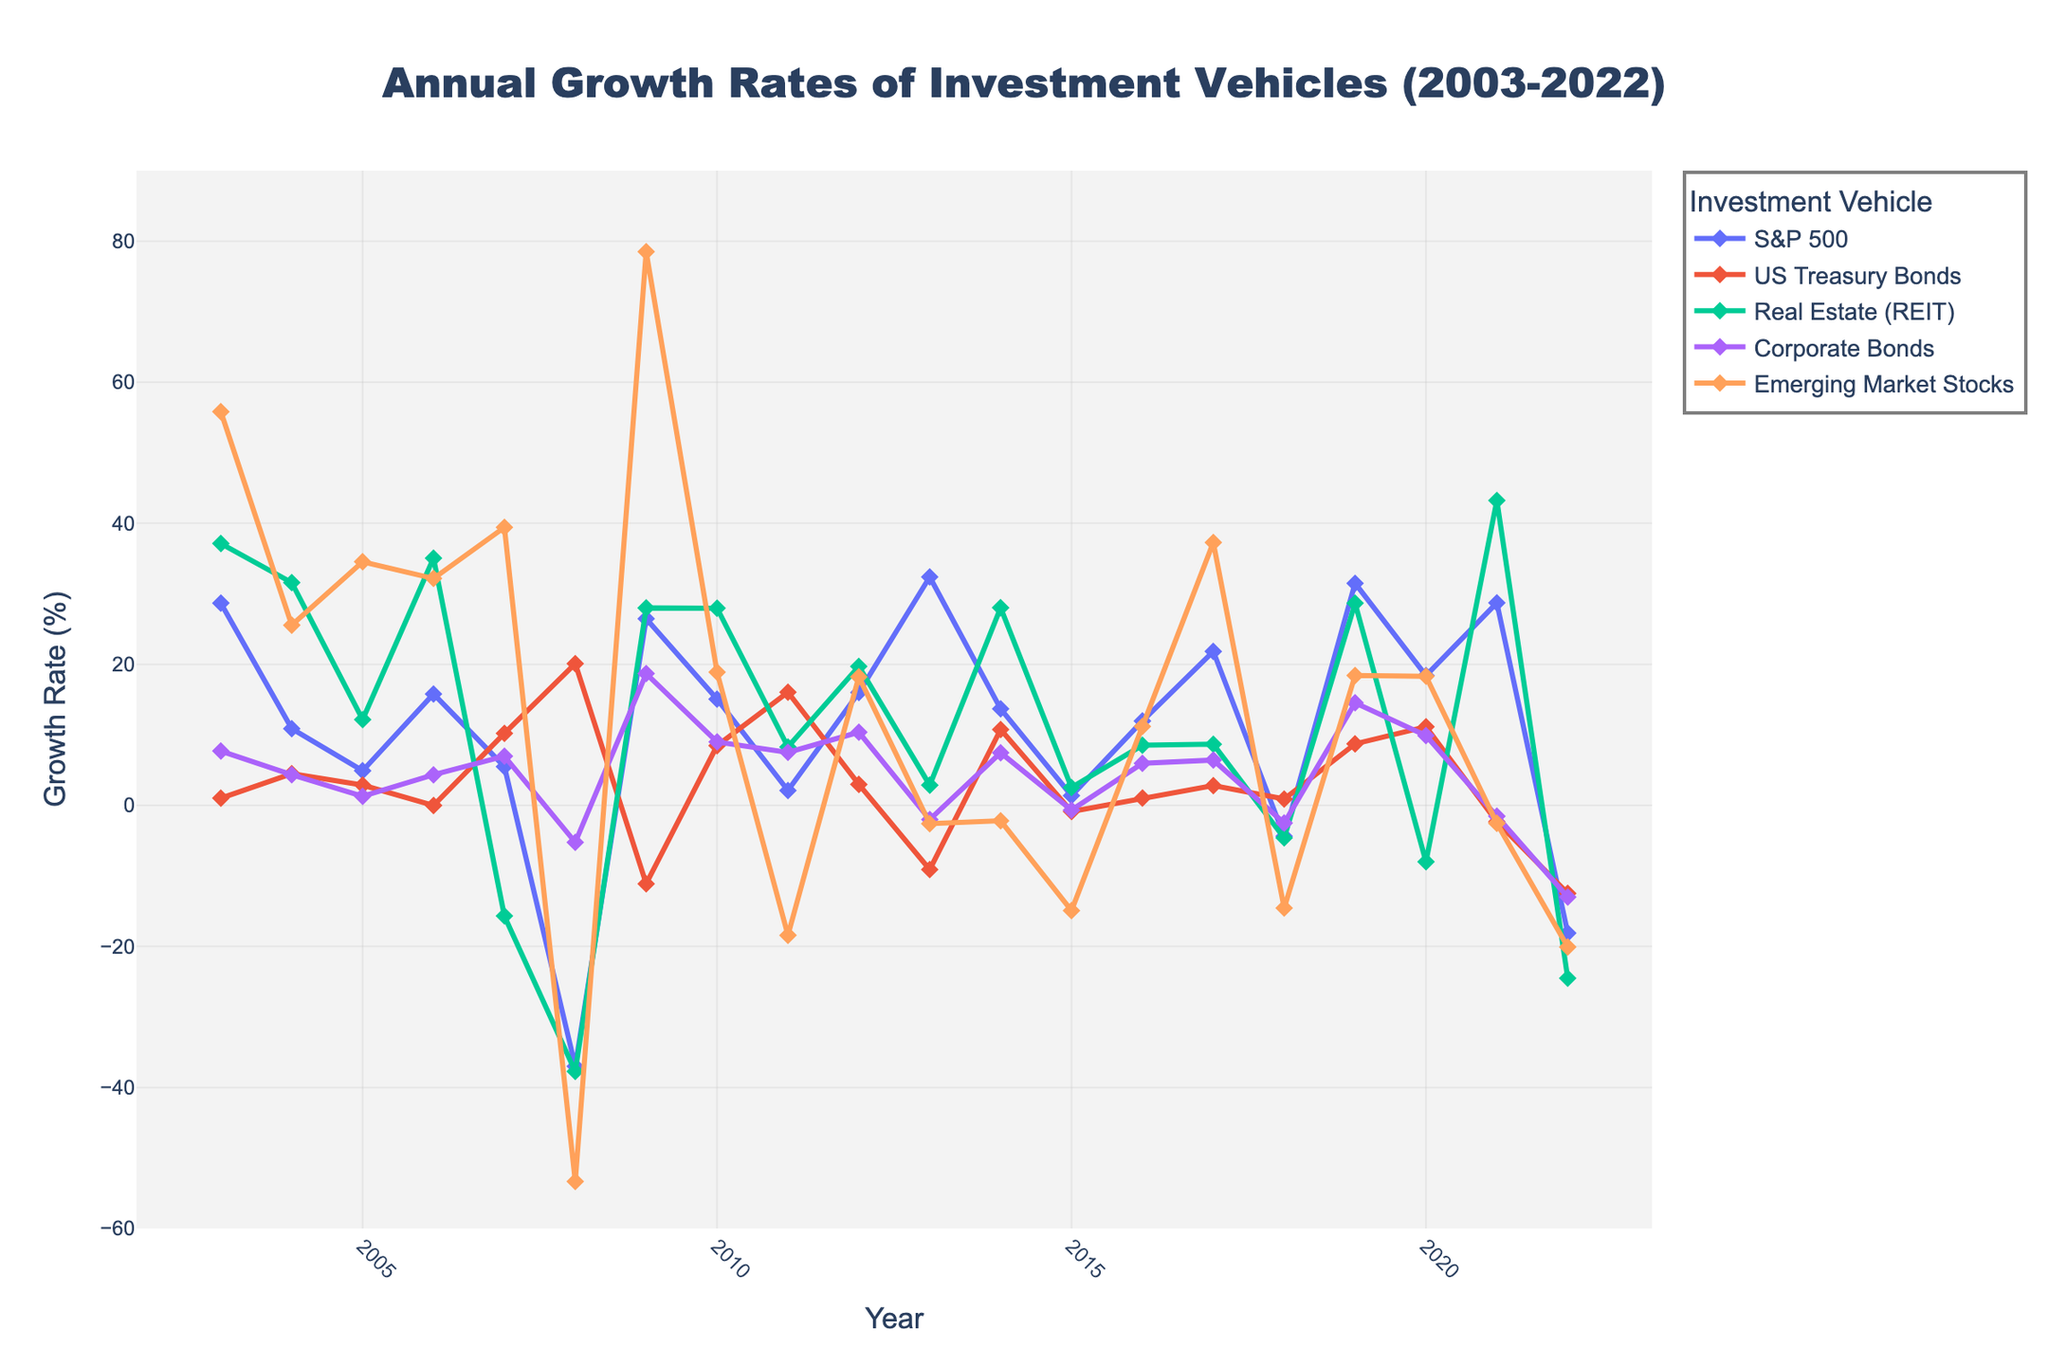What was the growth rate of S&P 500 in 2022 and how does it compare to 2008? Look at the S&P 500 data points for 2022 and 2008. In 2022, the growth rate is -18.11% and in 2008, it is -37.00%. The S&P 500 had a higher growth rate (less negative) in 2022 compared to 2008.
Answer: -18.11% in 2022 vs -37.00% in 2008 Which investment vehicle had the highest growth rate in 2019? Identify the line representing the year 2019 and compare the peaks. Emerging Market Stocks had a growth rate of 18.42%, Corporate Bonds had 14.54%, US Treasury Bonds had 8.72%, Real Estate (REIT) had 28.66%, and S&P 500 had 31.49%. S&P 500 had the highest growth rate in 2019.
Answer: S&P 500 What was the overall trend for Real Estate (REIT) from 2003 to 2022? Examine the line representing Real Estate (REIT) over the years from 2003 to 2022. Observe the fluctuations and the direction of the peaks. It started strong, experienced significant drops in 2007, 2008, 2015, and then large drops again in 2022.
Answer: Fluctuating with significant drops How did Emerging Market Stocks perform in 2008 compared to Corporate Bonds? Look at the data points for 2008 for both Emerging Market Stocks (-53.33%) and Corporate Bonds (-5.24%). Emerging Market Stocks performed much worse than Corporate Bonds in 2008.
Answer: Worse In which years did US Treasury Bonds have a negative growth rate? Analyze the US Treasury Bonds line and identify the years where the growth rate drops below 0%: 2006, 2009, 2013, 2015, 2021, and 2022 had negative growth rates.
Answer: 2006, 2009, 2013, 2015, 2021, and 2022 What was the most volatile investment vehicle over the 20 years, based on peaks and troughs? Compare the fluctuations in the lines of each investment vehicle. Emerging Market Stocks had significant peaks and troughs, especially with a huge peak in 2003 and a significant drop in 2008.
Answer: Emerging Market Stocks What was the average growth rate for Corporate Bonds between 2010 and 2015? Calculate the average of Corporate Bonds growth rates for 2010 (9.00%), 2011 (7.51%), 2012 (10.37%), 2013 (-2.01%), 2014 (7.46%), and 2015 (-0.68%). Sum these (9.00 + 7.51 + 10.37 + (-2.01) + 7.46 + (-0.68)) = 31.65 and then divide by 6.
Answer: 5.275% Compare the performance of Real Estate (REIT) in 2007 and 2009. Examine the growth rates for Real Estate (REIT) in 2007 (-15.69%) and 2009 (27.99%). The performance shifted from negative in 2007 to a positive growth rate in 2009.
Answer: Improved Which investment vehicle had the worst performance in 2022 and what was its growth rate? Look at the data points for 2022 and compare the values. Emerging Market Stocks had the worst performance with a growth rate of -20.09%.
Answer: Emerging Market Stocks, -20.09% What is the difference between the maximum and minimum growth rates of the S&P 500 during 2003-2022? Identify the maximum (32.39% in 2013) and the minimum (-37.00% in 2008) growth rates for S&P 500, then calculate the difference: 32.39 - (-37.00) = 69.39%.
Answer: 69.39% 